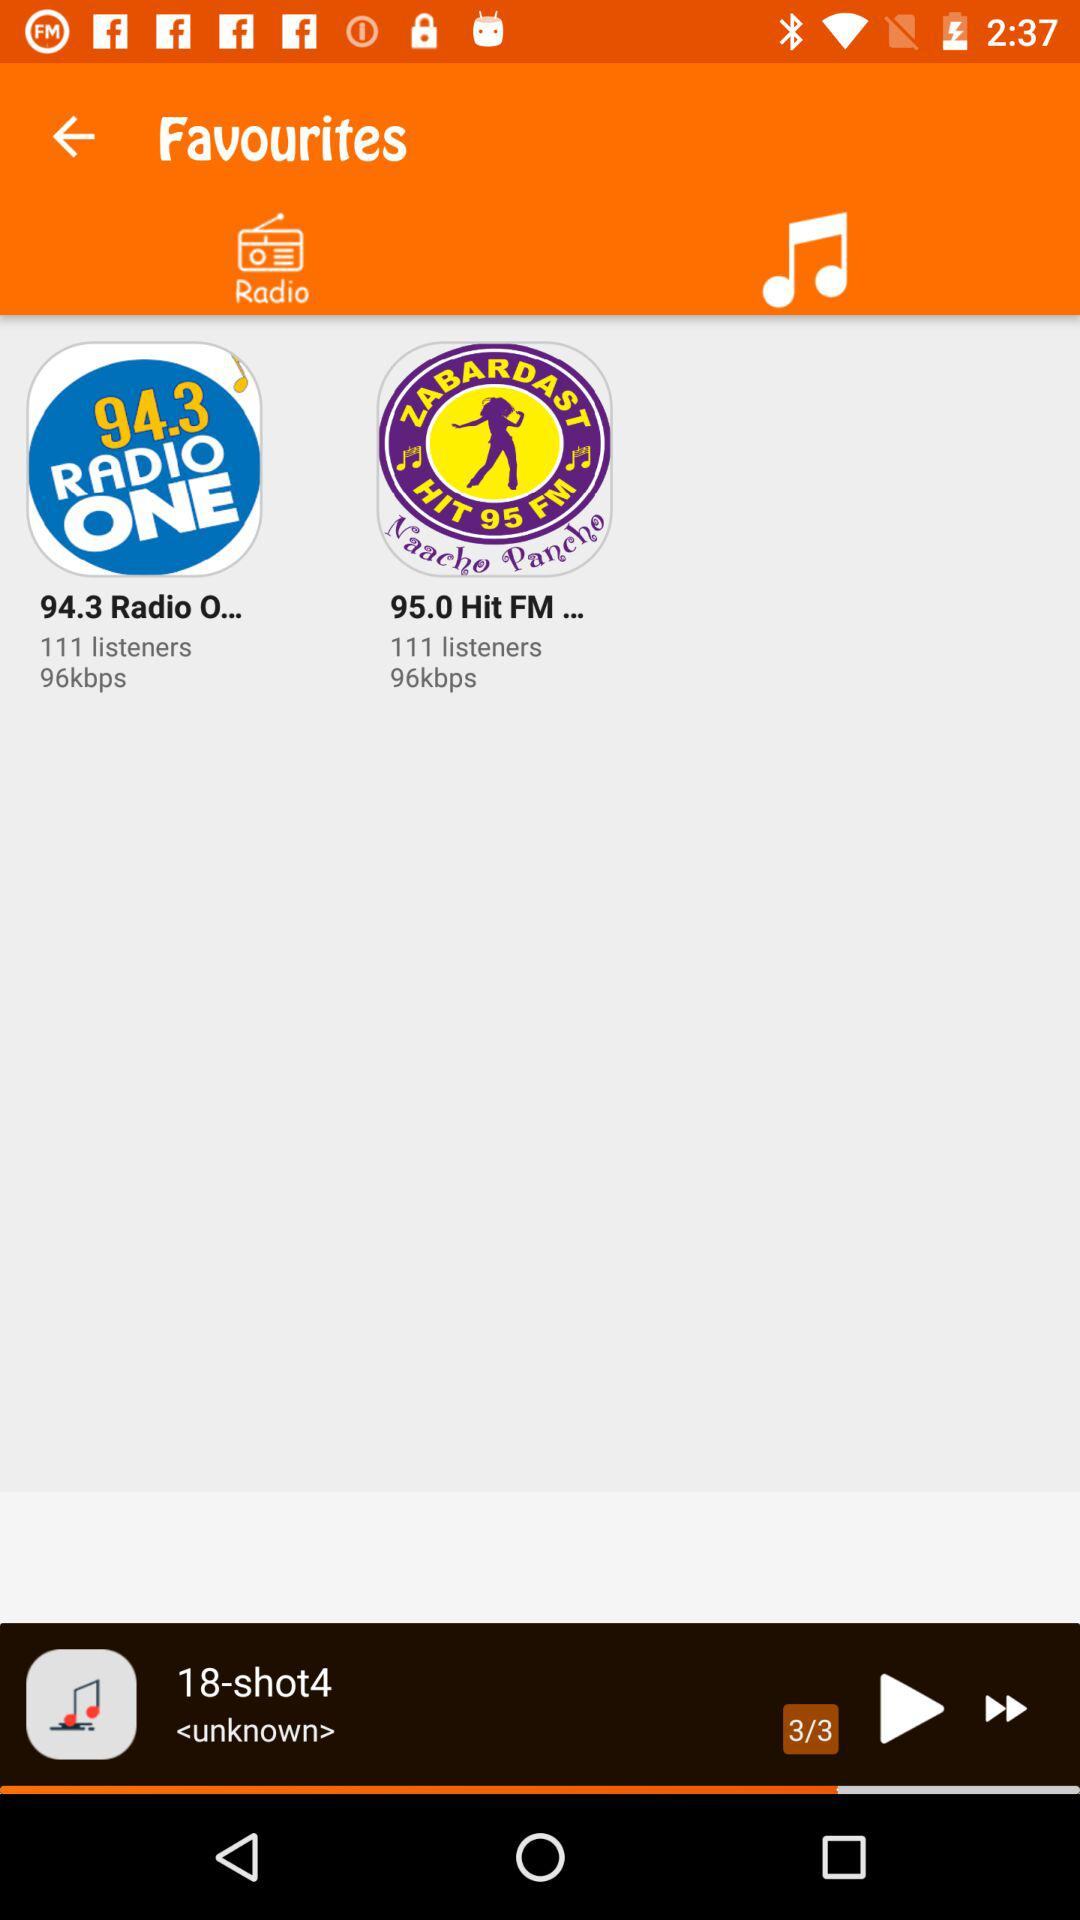How many people listen to "94.3 RADIO ONE"? There are 111 people. 